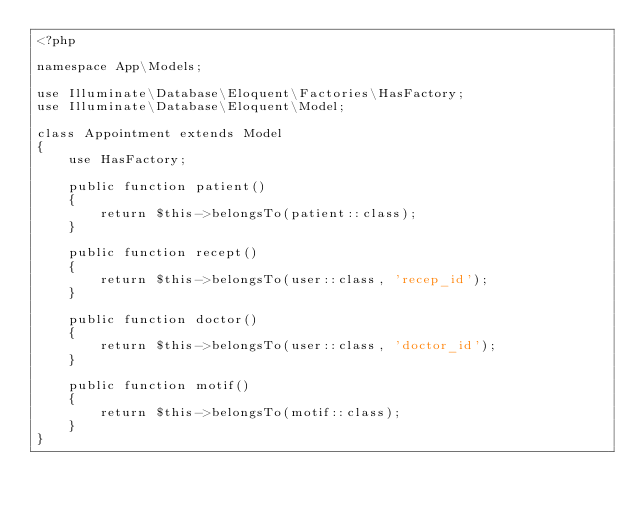<code> <loc_0><loc_0><loc_500><loc_500><_PHP_><?php

namespace App\Models;

use Illuminate\Database\Eloquent\Factories\HasFactory;
use Illuminate\Database\Eloquent\Model;

class Appointment extends Model
{
    use HasFactory;

    public function patient()
    {
        return $this->belongsTo(patient::class);
    }

    public function recept()
    {
        return $this->belongsTo(user::class, 'recep_id');
    }

    public function doctor()
    {
        return $this->belongsTo(user::class, 'doctor_id');
    }

    public function motif()
    {
        return $this->belongsTo(motif::class);
    }
}
</code> 